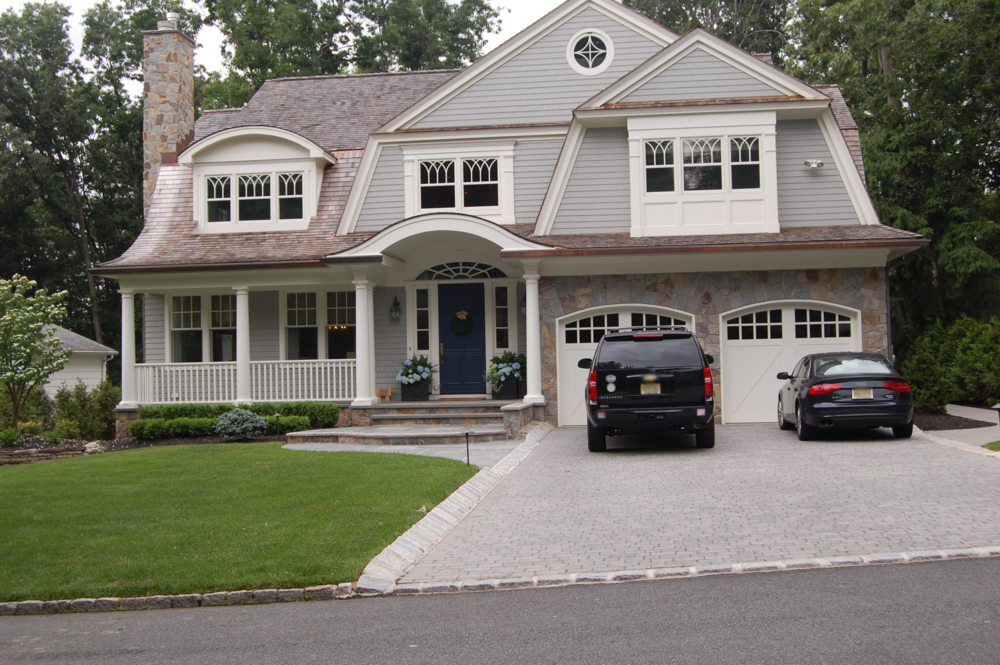Could you describe a day in the life of a family living in this house? A family living in this charming Craftsman-style house enjoys a balanced blend of modern convenience and classic comfort. In the morning, sunlight floods the spacious kitchen where breakfast is prepared. The children might enjoy their morning cereal seated at the inviting kitchen bar while their parents sip coffee on the porch, enjoying the serene view of the garden. The day progresses with various activities: perhaps a walk or bike ride around the picturesque neighborhood, and some time in the home’s cozy study for remote work or reading. Lunchtime might be a casual affair in the dining room, with large windows bringing in natural light. In the afternoon, the family might host friends for a barbecue in the lush backyard or relax in the living room, where the fireplace adds a cozy touch. As the evening falls, dinner could be a more formal event in the dining room, followed by some quiet family time watching a movie or playing board games. Nighttime indoor and outdoor lights create a peaceful ambiance, ending the day on a tranquil note. 